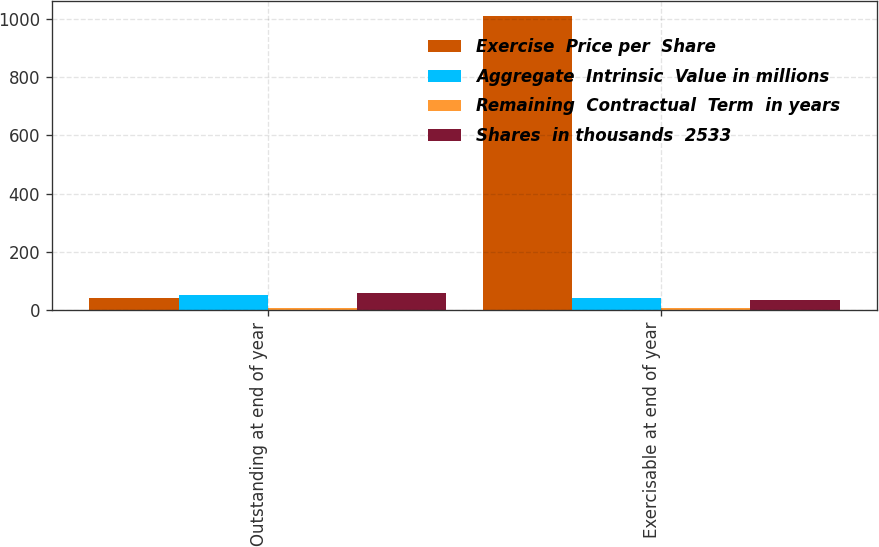Convert chart. <chart><loc_0><loc_0><loc_500><loc_500><stacked_bar_chart><ecel><fcel>Outstanding at end of year<fcel>Exercisable at end of year<nl><fcel>Exercise  Price per  Share<fcel>43.16<fcel>1009<nl><fcel>Aggregate  Intrinsic  Value in millions<fcel>50.48<fcel>43.16<nl><fcel>Remaining  Contractual  Term  in years<fcel>7.1<fcel>5.5<nl><fcel>Shares  in thousands  2533<fcel>58<fcel>34.5<nl></chart> 